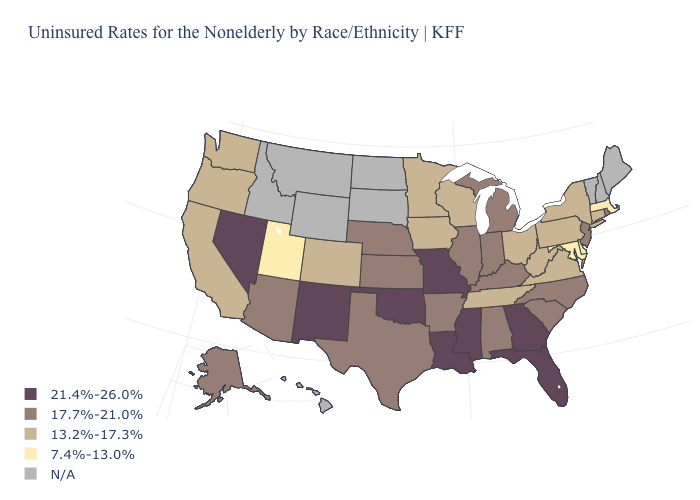Does Delaware have the lowest value in the USA?
Concise answer only. Yes. What is the value of New York?
Concise answer only. 13.2%-17.3%. What is the highest value in the West ?
Write a very short answer. 21.4%-26.0%. Name the states that have a value in the range N/A?
Quick response, please. Hawaii, Idaho, Maine, Montana, New Hampshire, North Dakota, South Dakota, Vermont, Wyoming. Name the states that have a value in the range 21.4%-26.0%?
Short answer required. Florida, Georgia, Louisiana, Mississippi, Missouri, Nevada, New Mexico, Oklahoma. Which states have the lowest value in the USA?
Write a very short answer. Delaware, Maryland, Massachusetts, Utah. Among the states that border Utah , which have the highest value?
Write a very short answer. Nevada, New Mexico. What is the highest value in the USA?
Short answer required. 21.4%-26.0%. What is the value of Minnesota?
Be succinct. 13.2%-17.3%. Does Pennsylvania have the highest value in the Northeast?
Answer briefly. No. Name the states that have a value in the range 17.7%-21.0%?
Give a very brief answer. Alabama, Alaska, Arizona, Arkansas, Illinois, Indiana, Kansas, Kentucky, Michigan, Nebraska, New Jersey, North Carolina, Rhode Island, South Carolina, Texas. What is the value of Kentucky?
Keep it brief. 17.7%-21.0%. What is the value of Kansas?
Keep it brief. 17.7%-21.0%. 